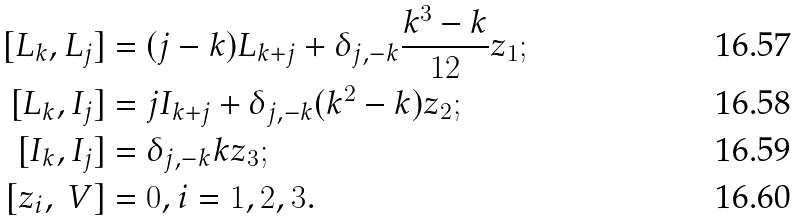Convert formula to latex. <formula><loc_0><loc_0><loc_500><loc_500>[ L _ { k } , L _ { j } ] & = ( j - k ) L _ { k + j } + \delta _ { j , - k } \frac { k ^ { 3 } - k } { 1 2 } z _ { 1 } ; \\ [ L _ { k } , I _ { j } ] & = j I _ { k + j } + \delta _ { j , - k } ( k ^ { 2 } - k ) z _ { 2 } ; \\ [ I _ { k } , I _ { j } ] & = \delta _ { j , - k } k z _ { 3 } ; \\ [ z _ { i } , \ V ] & = 0 , i = 1 , 2 , 3 .</formula> 